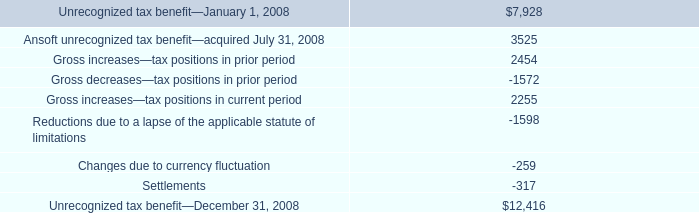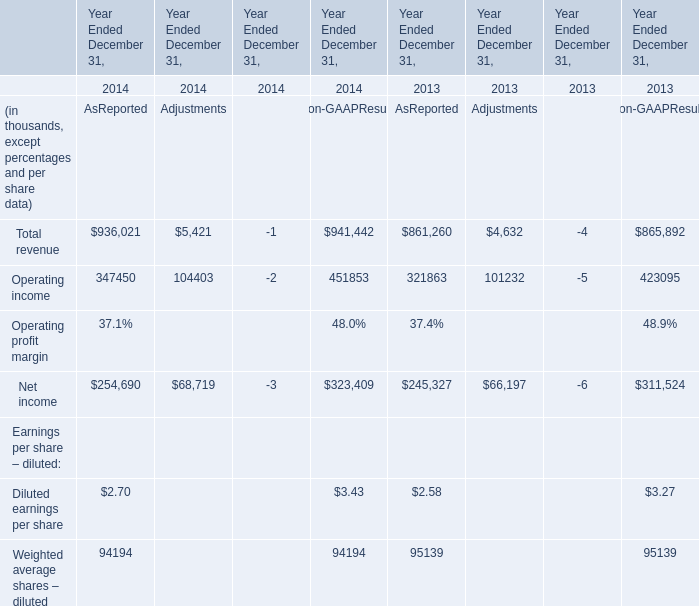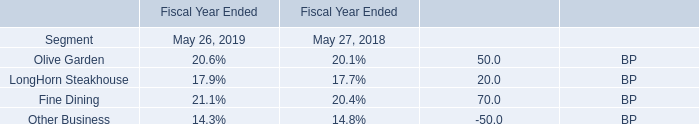What's the average of Net income of Year Ended December 31, 2013 Adjustments, and Gross increases—tax positions in prior period ? 
Computations: ((66197.0 + 2454.0) / 2)
Answer: 34325.5. 